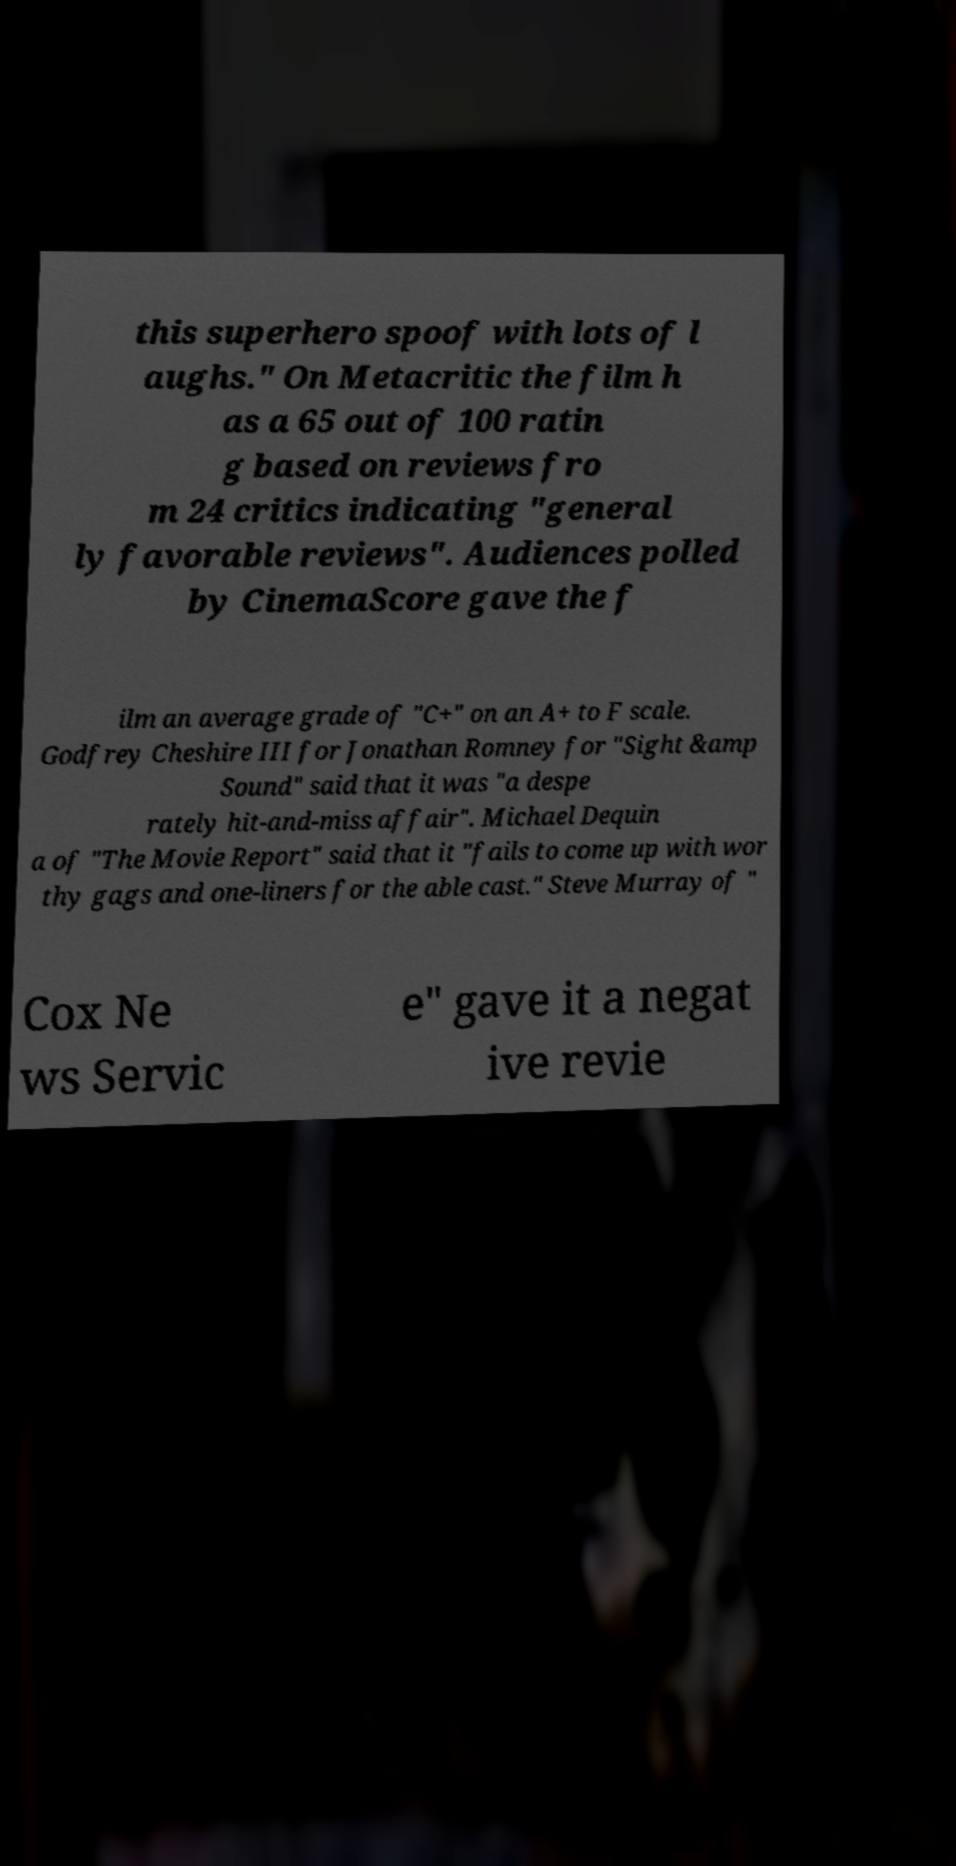Could you extract and type out the text from this image? this superhero spoof with lots of l aughs." On Metacritic the film h as a 65 out of 100 ratin g based on reviews fro m 24 critics indicating "general ly favorable reviews". Audiences polled by CinemaScore gave the f ilm an average grade of "C+" on an A+ to F scale. Godfrey Cheshire III for Jonathan Romney for "Sight &amp Sound" said that it was "a despe rately hit-and-miss affair". Michael Dequin a of "The Movie Report" said that it "fails to come up with wor thy gags and one-liners for the able cast." Steve Murray of " Cox Ne ws Servic e" gave it a negat ive revie 